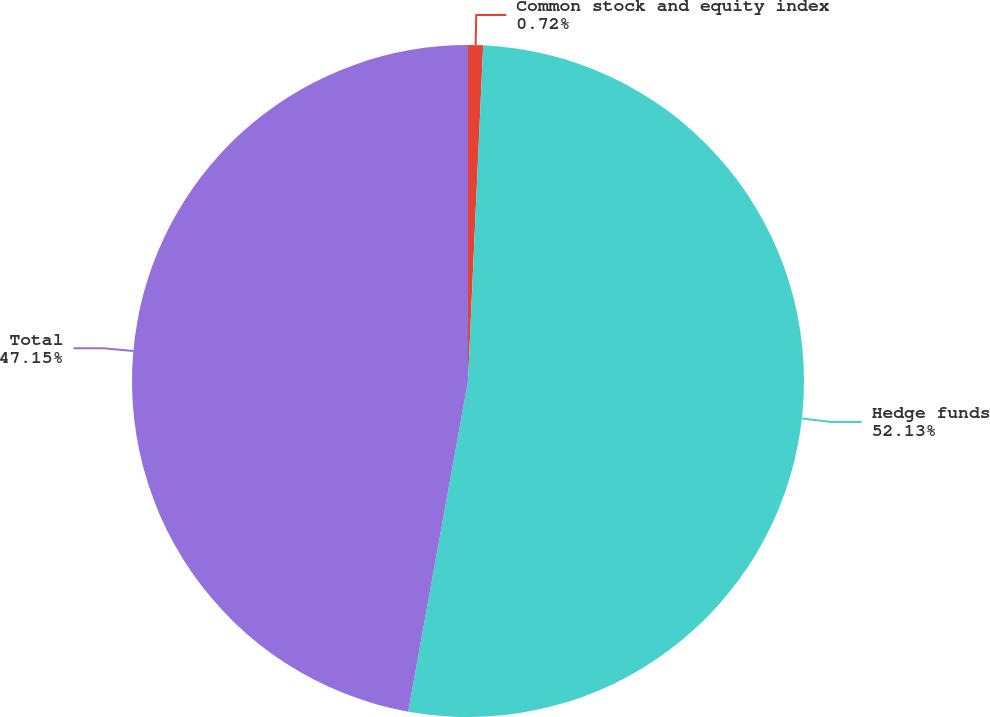Convert chart. <chart><loc_0><loc_0><loc_500><loc_500><pie_chart><fcel>Common stock and equity index<fcel>Hedge funds<fcel>Total<nl><fcel>0.72%<fcel>52.13%<fcel>47.15%<nl></chart> 